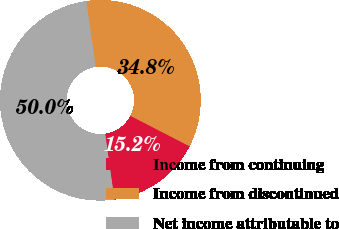Convert chart to OTSL. <chart><loc_0><loc_0><loc_500><loc_500><pie_chart><fcel>Income from continuing<fcel>Income from discontinued<fcel>Net income attributable to<nl><fcel>15.2%<fcel>34.8%<fcel>50.0%<nl></chart> 